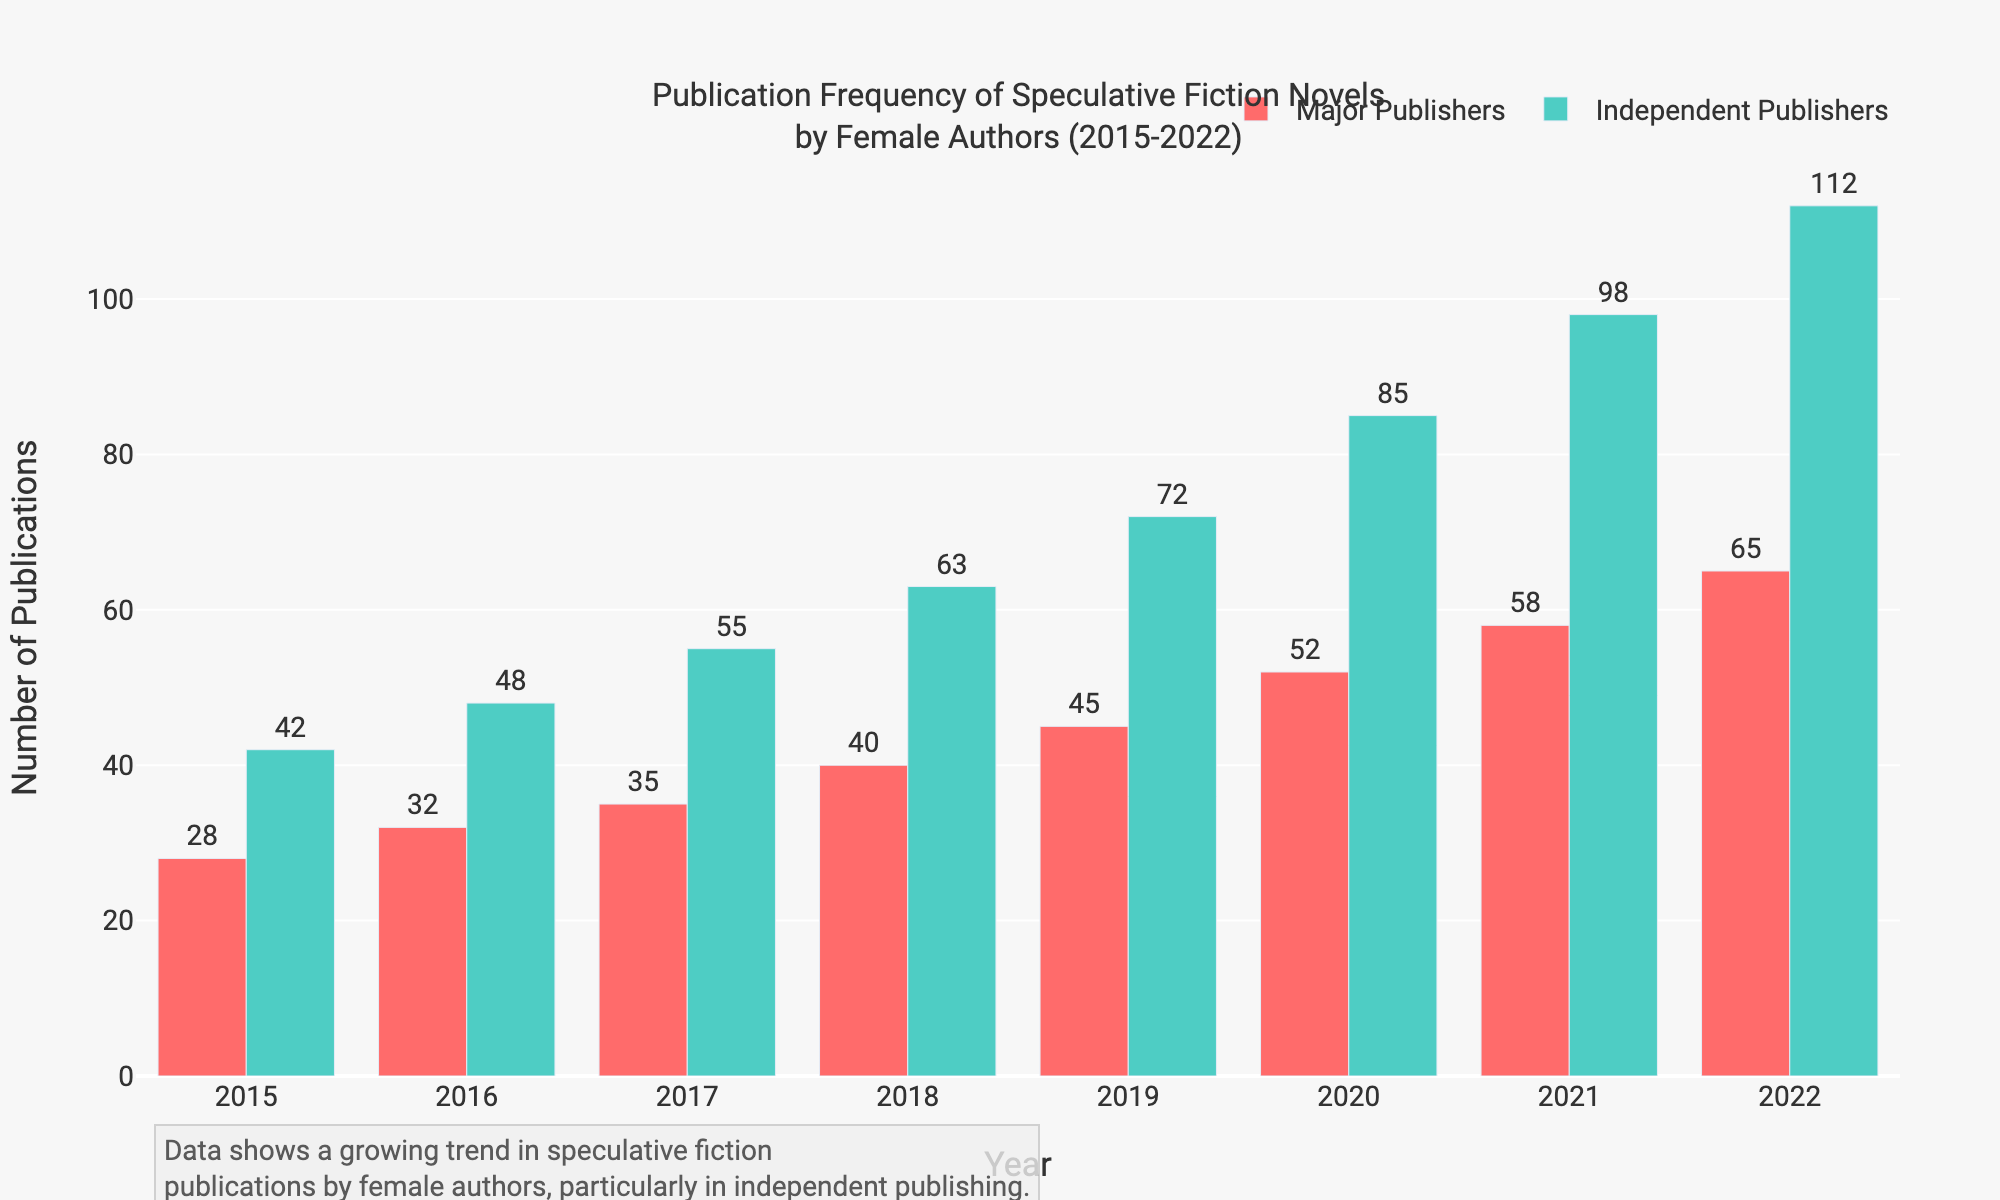Which year saw the highest number of publications by independent publishers? From the figure, observe the height of the green bars representing 'Independent Publishers'. The tallest bar is in the year 2022.
Answer: 2022 Did major publishers or independent publishers publish more speculative fiction novels by female authors in 2019? Compare the heights of the red and green bars for the year 2019. The green bar (independent publishers) is taller.
Answer: Independent Publishers By how much did the total number of publications by major publishers increase from 2015 to 2022? Subtract the number of publications in 2015 from that in 2022 for major publishers: 65 - 28.
Answer: 37 What is the total number of speculative fiction novels published by female authors in 2020 by both major and independent publishers? Add the numbers for major and independent publishers in 2020: 52 (major) + 85 (independent).
Answer: 137 Which year showed the largest difference in publications between major and independent publishers? Calculate the differences for each year and identify the largest: 14 (2015), 16 (2016), 20 (2017), 23 (2018), 27 (2019), 33 (2020), 40 (2021), 47 (2022). The largest difference is 47 in 2022.
Answer: 2022 How did the number of publications by major publishers in 2018 compare to those by independent publishers in the same year? Compare the green and red bars for 2018. The green bar (independent publishers) is taller.
Answer: Independent Publishers had more Which year had an equal or almost equal number of publications by major and independent publishers? By visually comparing the heights of the bars each year, it appears that no year has equal bars, but the year 2016 has the smallest difference (16-32 and 48).
Answer: None, but 2016 is closest By what percentage did major publishers' publications increase from 2020 to 2021? Calculate the percentage increase: \(((58 - 52)/52) * 100 = 11.5\%\).
Answer: 11.5% What is the average number of publications per year by independent publishers over the period 2015-2022? Sum the independent publications over all years and divide by the number of years: \((42 + 48 + 55 + 63 + 72 + 85 + 98 + 112) / 8 = 71.875\).
Answer: 71.875 